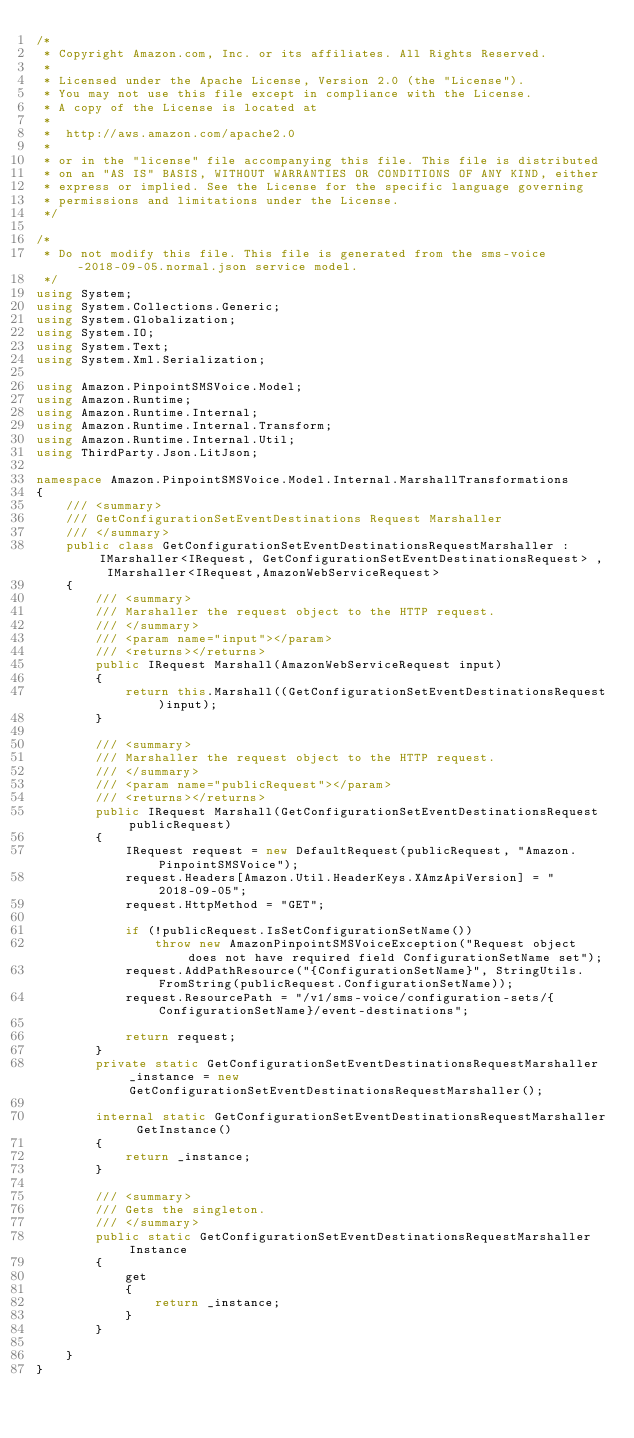<code> <loc_0><loc_0><loc_500><loc_500><_C#_>/*
 * Copyright Amazon.com, Inc. or its affiliates. All Rights Reserved.
 * 
 * Licensed under the Apache License, Version 2.0 (the "License").
 * You may not use this file except in compliance with the License.
 * A copy of the License is located at
 * 
 *  http://aws.amazon.com/apache2.0
 * 
 * or in the "license" file accompanying this file. This file is distributed
 * on an "AS IS" BASIS, WITHOUT WARRANTIES OR CONDITIONS OF ANY KIND, either
 * express or implied. See the License for the specific language governing
 * permissions and limitations under the License.
 */

/*
 * Do not modify this file. This file is generated from the sms-voice-2018-09-05.normal.json service model.
 */
using System;
using System.Collections.Generic;
using System.Globalization;
using System.IO;
using System.Text;
using System.Xml.Serialization;

using Amazon.PinpointSMSVoice.Model;
using Amazon.Runtime;
using Amazon.Runtime.Internal;
using Amazon.Runtime.Internal.Transform;
using Amazon.Runtime.Internal.Util;
using ThirdParty.Json.LitJson;

namespace Amazon.PinpointSMSVoice.Model.Internal.MarshallTransformations
{
    /// <summary>
    /// GetConfigurationSetEventDestinations Request Marshaller
    /// </summary>       
    public class GetConfigurationSetEventDestinationsRequestMarshaller : IMarshaller<IRequest, GetConfigurationSetEventDestinationsRequest> , IMarshaller<IRequest,AmazonWebServiceRequest>
    {
        /// <summary>
        /// Marshaller the request object to the HTTP request.
        /// </summary>  
        /// <param name="input"></param>
        /// <returns></returns>
        public IRequest Marshall(AmazonWebServiceRequest input)
        {
            return this.Marshall((GetConfigurationSetEventDestinationsRequest)input);
        }

        /// <summary>
        /// Marshaller the request object to the HTTP request.
        /// </summary>  
        /// <param name="publicRequest"></param>
        /// <returns></returns>
        public IRequest Marshall(GetConfigurationSetEventDestinationsRequest publicRequest)
        {
            IRequest request = new DefaultRequest(publicRequest, "Amazon.PinpointSMSVoice");
            request.Headers[Amazon.Util.HeaderKeys.XAmzApiVersion] = "2018-09-05";
            request.HttpMethod = "GET";

            if (!publicRequest.IsSetConfigurationSetName())
                throw new AmazonPinpointSMSVoiceException("Request object does not have required field ConfigurationSetName set");
            request.AddPathResource("{ConfigurationSetName}", StringUtils.FromString(publicRequest.ConfigurationSetName));
            request.ResourcePath = "/v1/sms-voice/configuration-sets/{ConfigurationSetName}/event-destinations";

            return request;
        }
        private static GetConfigurationSetEventDestinationsRequestMarshaller _instance = new GetConfigurationSetEventDestinationsRequestMarshaller();        

        internal static GetConfigurationSetEventDestinationsRequestMarshaller GetInstance()
        {
            return _instance;
        }

        /// <summary>
        /// Gets the singleton.
        /// </summary>  
        public static GetConfigurationSetEventDestinationsRequestMarshaller Instance
        {
            get
            {
                return _instance;
            }
        }

    }
}</code> 